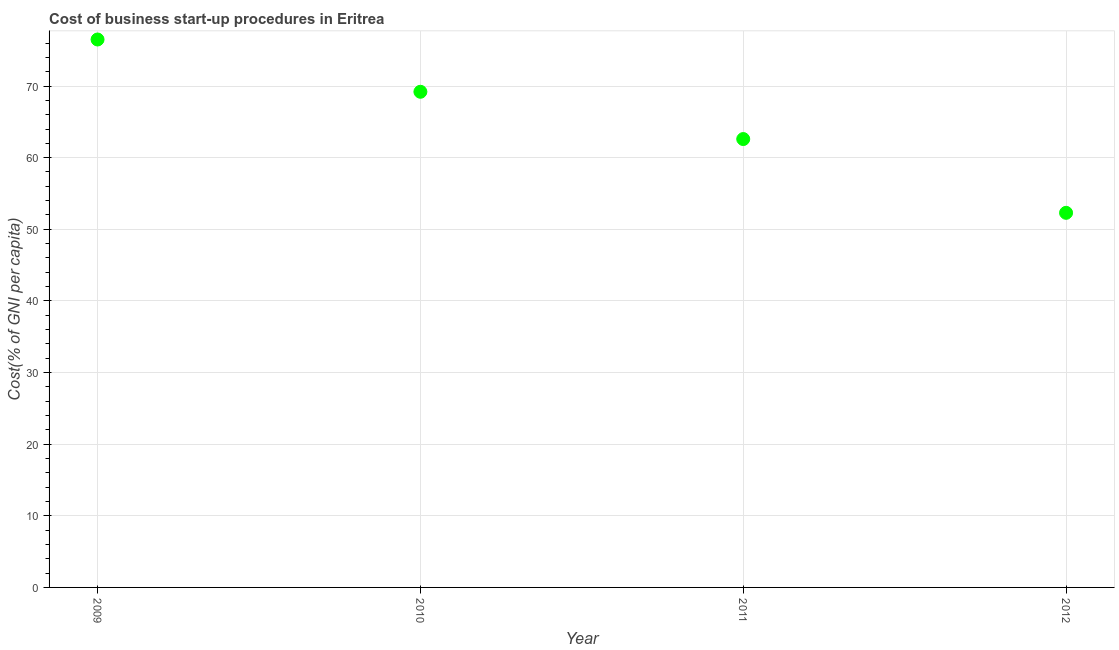What is the cost of business startup procedures in 2012?
Ensure brevity in your answer.  52.3. Across all years, what is the maximum cost of business startup procedures?
Keep it short and to the point. 76.5. Across all years, what is the minimum cost of business startup procedures?
Your response must be concise. 52.3. In which year was the cost of business startup procedures maximum?
Offer a very short reply. 2009. In which year was the cost of business startup procedures minimum?
Make the answer very short. 2012. What is the sum of the cost of business startup procedures?
Your response must be concise. 260.6. What is the difference between the cost of business startup procedures in 2010 and 2011?
Your response must be concise. 6.6. What is the average cost of business startup procedures per year?
Provide a succinct answer. 65.15. What is the median cost of business startup procedures?
Your answer should be very brief. 65.9. Do a majority of the years between 2009 and 2012 (inclusive) have cost of business startup procedures greater than 20 %?
Offer a very short reply. Yes. What is the ratio of the cost of business startup procedures in 2010 to that in 2011?
Ensure brevity in your answer.  1.11. What is the difference between the highest and the second highest cost of business startup procedures?
Your response must be concise. 7.3. What is the difference between the highest and the lowest cost of business startup procedures?
Give a very brief answer. 24.2. Does the cost of business startup procedures monotonically increase over the years?
Offer a very short reply. No. What is the title of the graph?
Give a very brief answer. Cost of business start-up procedures in Eritrea. What is the label or title of the Y-axis?
Give a very brief answer. Cost(% of GNI per capita). What is the Cost(% of GNI per capita) in 2009?
Your response must be concise. 76.5. What is the Cost(% of GNI per capita) in 2010?
Your answer should be compact. 69.2. What is the Cost(% of GNI per capita) in 2011?
Offer a terse response. 62.6. What is the Cost(% of GNI per capita) in 2012?
Make the answer very short. 52.3. What is the difference between the Cost(% of GNI per capita) in 2009 and 2011?
Ensure brevity in your answer.  13.9. What is the difference between the Cost(% of GNI per capita) in 2009 and 2012?
Your answer should be very brief. 24.2. What is the difference between the Cost(% of GNI per capita) in 2010 and 2012?
Give a very brief answer. 16.9. What is the difference between the Cost(% of GNI per capita) in 2011 and 2012?
Provide a short and direct response. 10.3. What is the ratio of the Cost(% of GNI per capita) in 2009 to that in 2010?
Provide a short and direct response. 1.1. What is the ratio of the Cost(% of GNI per capita) in 2009 to that in 2011?
Offer a very short reply. 1.22. What is the ratio of the Cost(% of GNI per capita) in 2009 to that in 2012?
Provide a short and direct response. 1.46. What is the ratio of the Cost(% of GNI per capita) in 2010 to that in 2011?
Give a very brief answer. 1.1. What is the ratio of the Cost(% of GNI per capita) in 2010 to that in 2012?
Your answer should be very brief. 1.32. What is the ratio of the Cost(% of GNI per capita) in 2011 to that in 2012?
Ensure brevity in your answer.  1.2. 